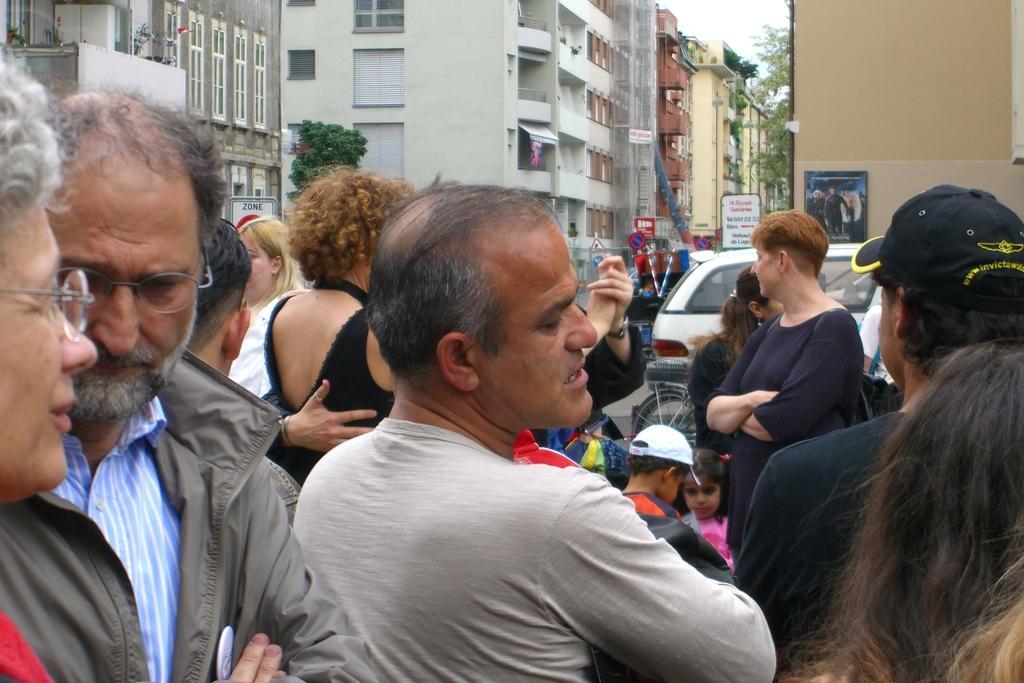How would you summarize this image in a sentence or two? In this image we can see the people and also the kids. We can also see the vehicle, bicycles, sign boards, txt boards, hoarding, trees and also the buildings. We can also see the sky. 